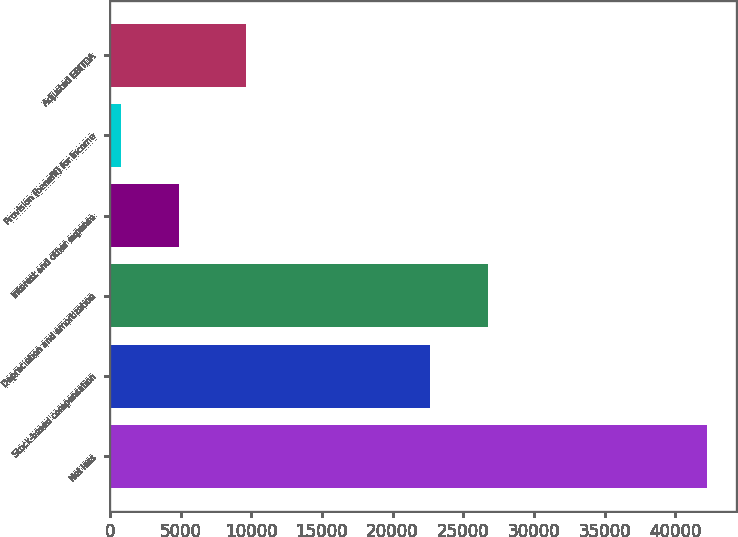Convert chart. <chart><loc_0><loc_0><loc_500><loc_500><bar_chart><fcel>Net loss<fcel>Stock-based compensation<fcel>Depreciation and amortization<fcel>Interest and other expense<fcel>Provision (benefit) for income<fcel>Adjusted EBITDA<nl><fcel>42225<fcel>22646<fcel>26790.8<fcel>4921.8<fcel>777<fcel>9647<nl></chart> 